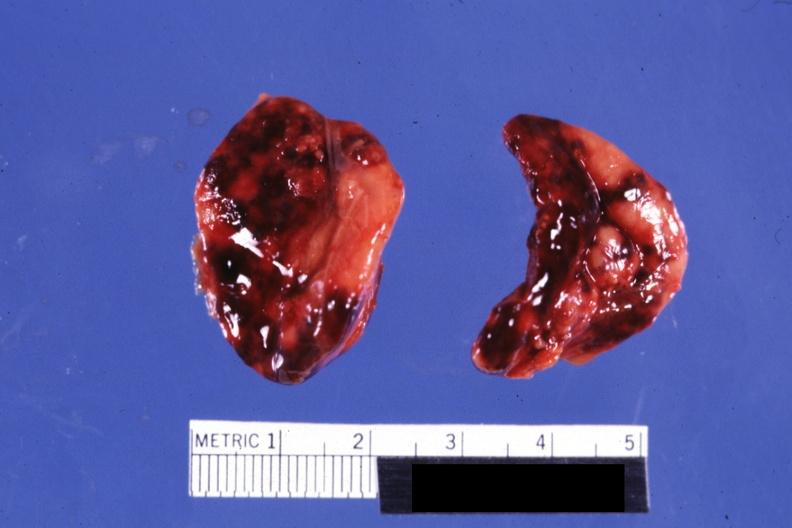what does this image show?
Answer the question using a single word or phrase. Both adrenals external views focal hemorrhages do not know history looks like placental abruption 